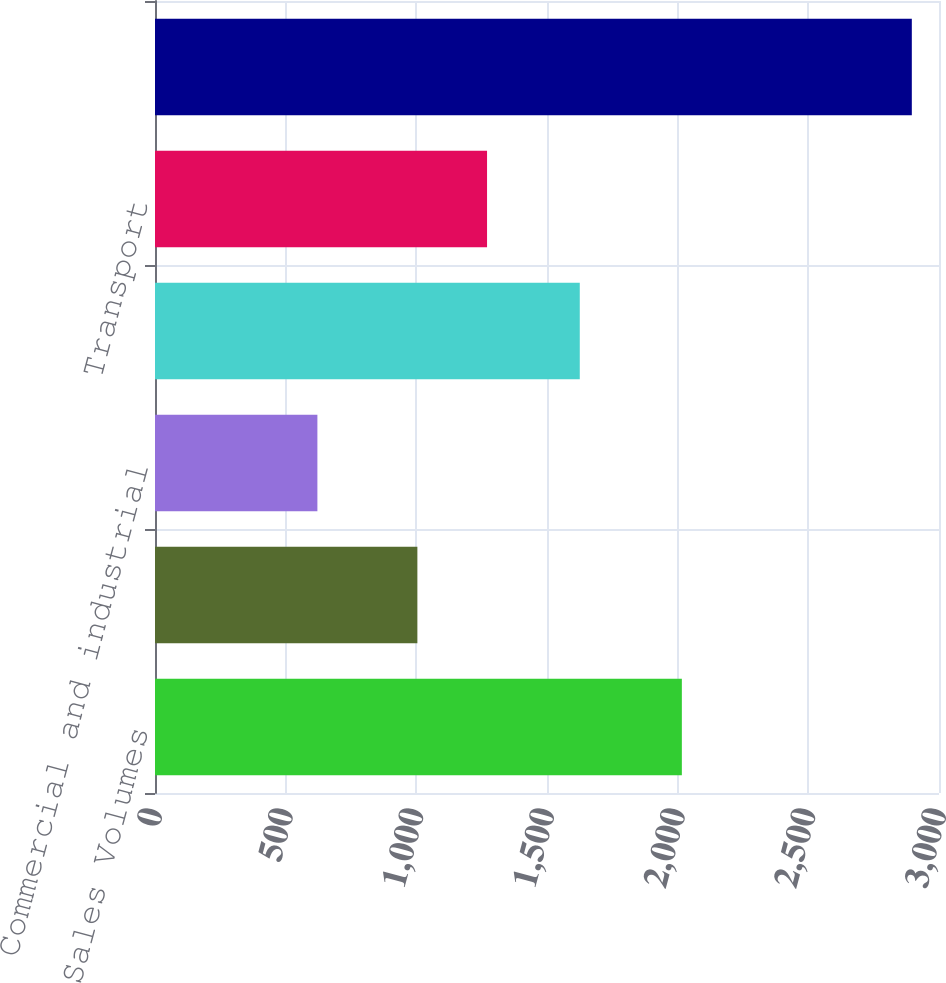Convert chart. <chart><loc_0><loc_0><loc_500><loc_500><bar_chart><fcel>Natural Gas Sales Volumes<fcel>Residential<fcel>Commercial and industrial<fcel>Total retail<fcel>Transport<fcel>Total sales in therms<nl><fcel>2016<fcel>1004<fcel>621.4<fcel>1625.4<fcel>1270.6<fcel>2896<nl></chart> 